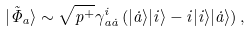Convert formula to latex. <formula><loc_0><loc_0><loc_500><loc_500>| \tilde { \Phi } _ { a } \rangle \sim \sqrt { p ^ { + } } \gamma ^ { i } _ { a \dot { a } } \left ( | \dot { a } \rangle | i \rangle - i | i \rangle | \dot { a } \rangle \right ) ,</formula> 